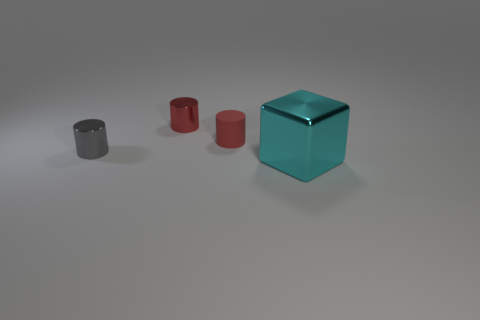Add 3 small red metallic objects. How many objects exist? 7 Subtract all cylinders. How many objects are left? 1 Add 4 tiny blue metal blocks. How many tiny blue metal blocks exist? 4 Subtract 0 green balls. How many objects are left? 4 Subtract all tiny gray objects. Subtract all metallic objects. How many objects are left? 0 Add 2 cylinders. How many cylinders are left? 5 